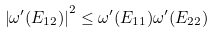Convert formula to latex. <formula><loc_0><loc_0><loc_500><loc_500>\left | \omega ^ { \prime } ( E _ { 1 2 } ) \right | ^ { 2 } \leq \omega ^ { \prime } ( E _ { 1 1 } ) \omega ^ { \prime } ( E _ { 2 2 } )</formula> 